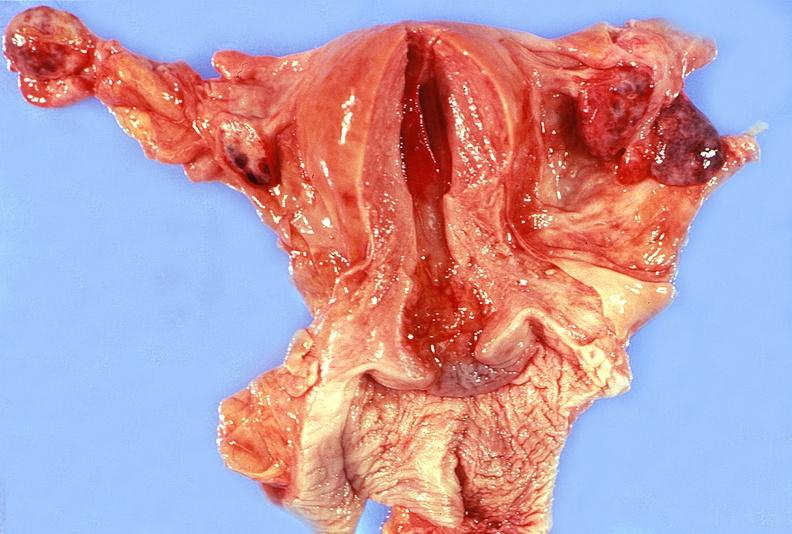where does this part belong to?
Answer the question using a single word or phrase. Female reproductive system 